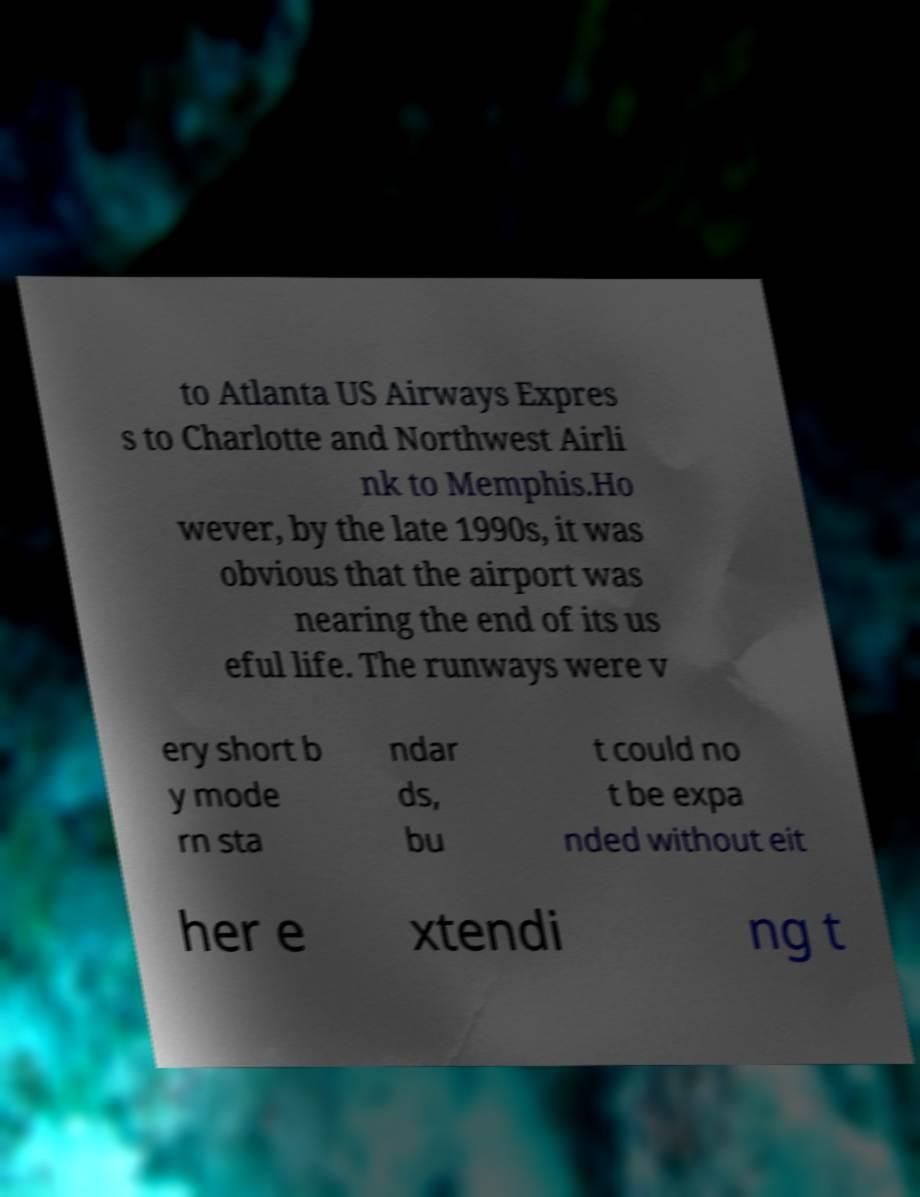Please identify and transcribe the text found in this image. to Atlanta US Airways Expres s to Charlotte and Northwest Airli nk to Memphis.Ho wever, by the late 1990s, it was obvious that the airport was nearing the end of its us eful life. The runways were v ery short b y mode rn sta ndar ds, bu t could no t be expa nded without eit her e xtendi ng t 